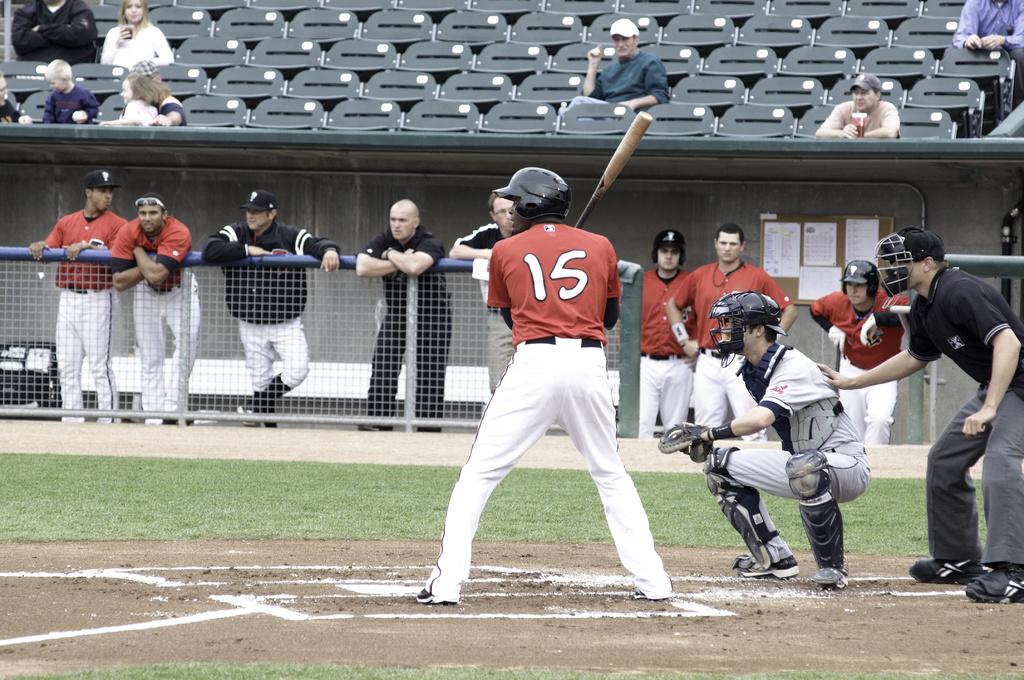What's the batter's jersey number?
Provide a succinct answer. 15. What color is the number 15 on the back of the jersey?
Your answer should be very brief. White. 